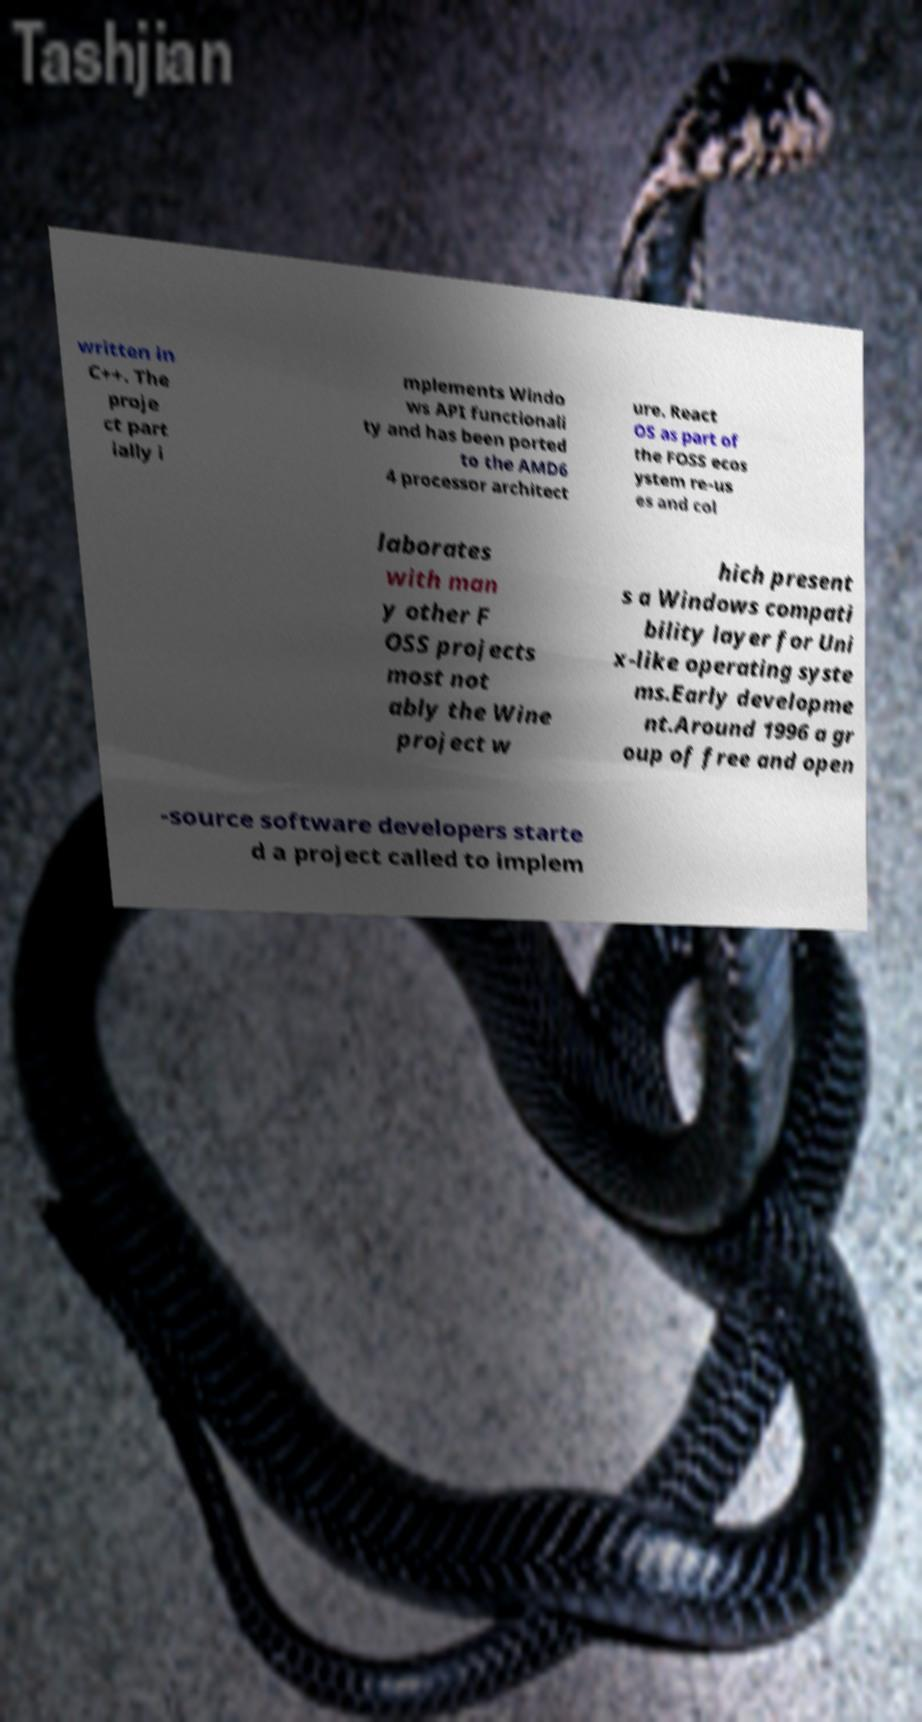Can you accurately transcribe the text from the provided image for me? written in C++. The proje ct part ially i mplements Windo ws API functionali ty and has been ported to the AMD6 4 processor architect ure. React OS as part of the FOSS ecos ystem re-us es and col laborates with man y other F OSS projects most not ably the Wine project w hich present s a Windows compati bility layer for Uni x-like operating syste ms.Early developme nt.Around 1996 a gr oup of free and open -source software developers starte d a project called to implem 